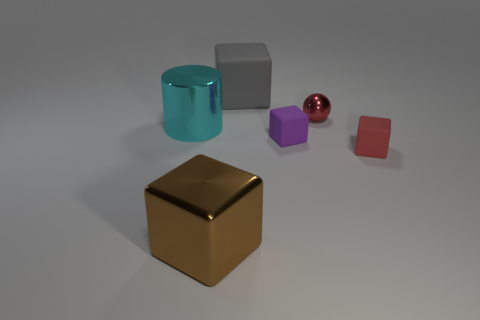Subtract all red cubes. Subtract all green cylinders. How many cubes are left? 3 Add 1 red shiny spheres. How many objects exist? 7 Subtract all cylinders. How many objects are left? 5 Add 6 tiny matte cubes. How many tiny matte cubes exist? 8 Subtract 1 brown cubes. How many objects are left? 5 Subtract all shiny spheres. Subtract all tiny red objects. How many objects are left? 3 Add 1 large cyan things. How many large cyan things are left? 2 